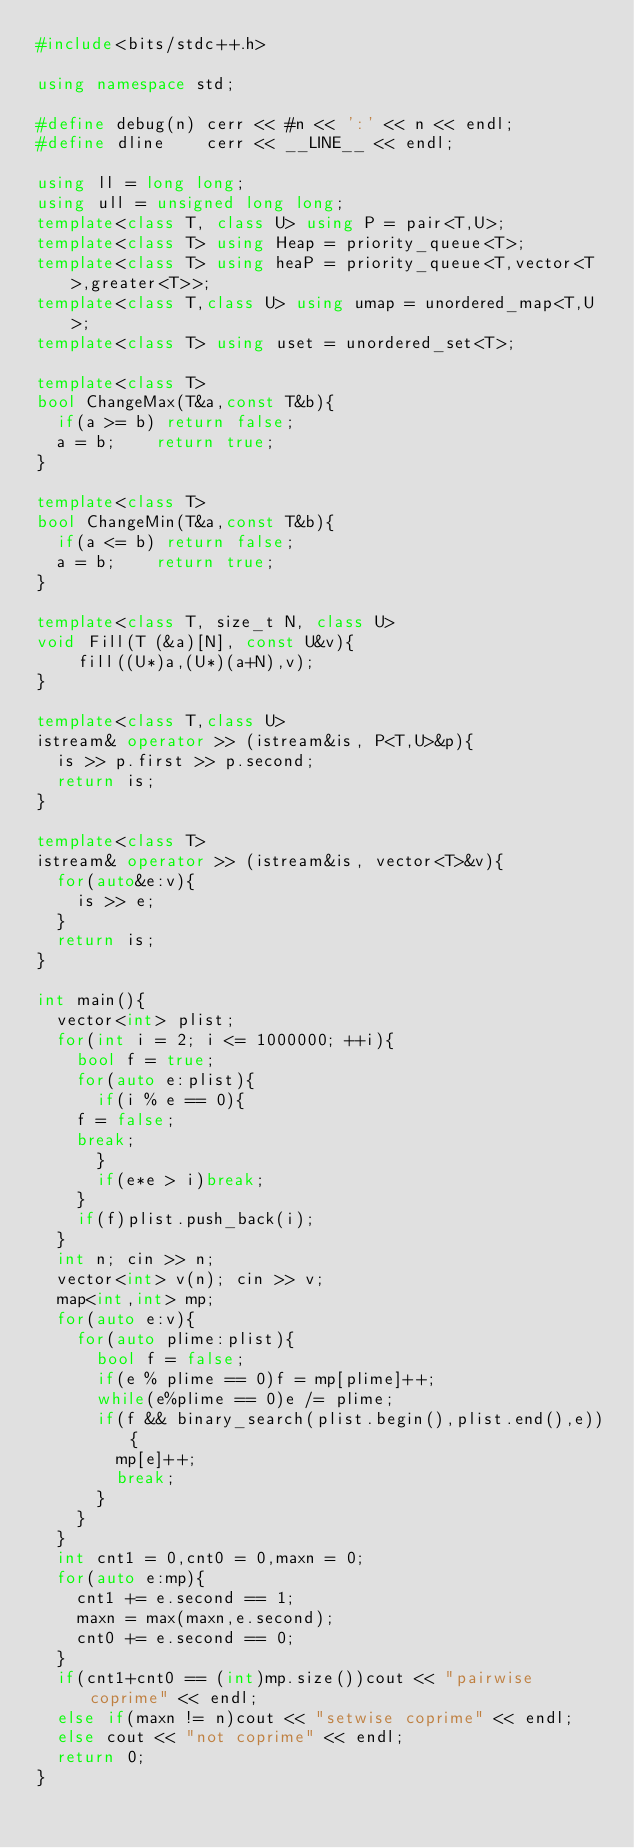<code> <loc_0><loc_0><loc_500><loc_500><_C++_>#include<bits/stdc++.h>

using namespace std;

#define debug(n) cerr << #n << ':' << n << endl;
#define dline    cerr << __LINE__ << endl;

using ll = long long;
using ull = unsigned long long;
template<class T, class U> using P = pair<T,U>;
template<class T> using Heap = priority_queue<T>;
template<class T> using heaP = priority_queue<T,vector<T>,greater<T>>;
template<class T,class U> using umap = unordered_map<T,U>;
template<class T> using uset = unordered_set<T>;

template<class T>
bool ChangeMax(T&a,const T&b){
  if(a >= b) return false;
  a = b;    return true;
}

template<class T>
bool ChangeMin(T&a,const T&b){
  if(a <= b) return false;
  a = b;    return true;  
}

template<class T, size_t N, class U>
void Fill(T (&a)[N], const U&v){
    fill((U*)a,(U*)(a+N),v);
}

template<class T,class U>
istream& operator >> (istream&is, P<T,U>&p){
  is >> p.first >> p.second;
  return is;
}

template<class T>
istream& operator >> (istream&is, vector<T>&v){
  for(auto&e:v){
    is >> e;
  }
  return is;
}

int main(){
  vector<int> plist;
  for(int i = 2; i <= 1000000; ++i){
    bool f = true;
    for(auto e:plist){
      if(i % e == 0){
	f = false;
	break;
      }
      if(e*e > i)break;
    }
    if(f)plist.push_back(i);
  }
  int n; cin >> n;
  vector<int> v(n); cin >> v;
  map<int,int> mp;
  for(auto e:v){
    for(auto plime:plist){
      bool f = false;
      if(e % plime == 0)f = mp[plime]++;
      while(e%plime == 0)e /= plime;
      if(f && binary_search(plist.begin(),plist.end(),e)){	
      	mp[e]++;
      	break;
      }
    }    
  }
  int cnt1 = 0,cnt0 = 0,maxn = 0;
  for(auto e:mp){
    cnt1 += e.second == 1;
    maxn = max(maxn,e.second);
    cnt0 += e.second == 0;
  }
  if(cnt1+cnt0 == (int)mp.size())cout << "pairwise coprime" << endl;
  else if(maxn != n)cout << "setwise coprime" << endl;
  else cout << "not coprime" << endl;
  return 0;
}
</code> 